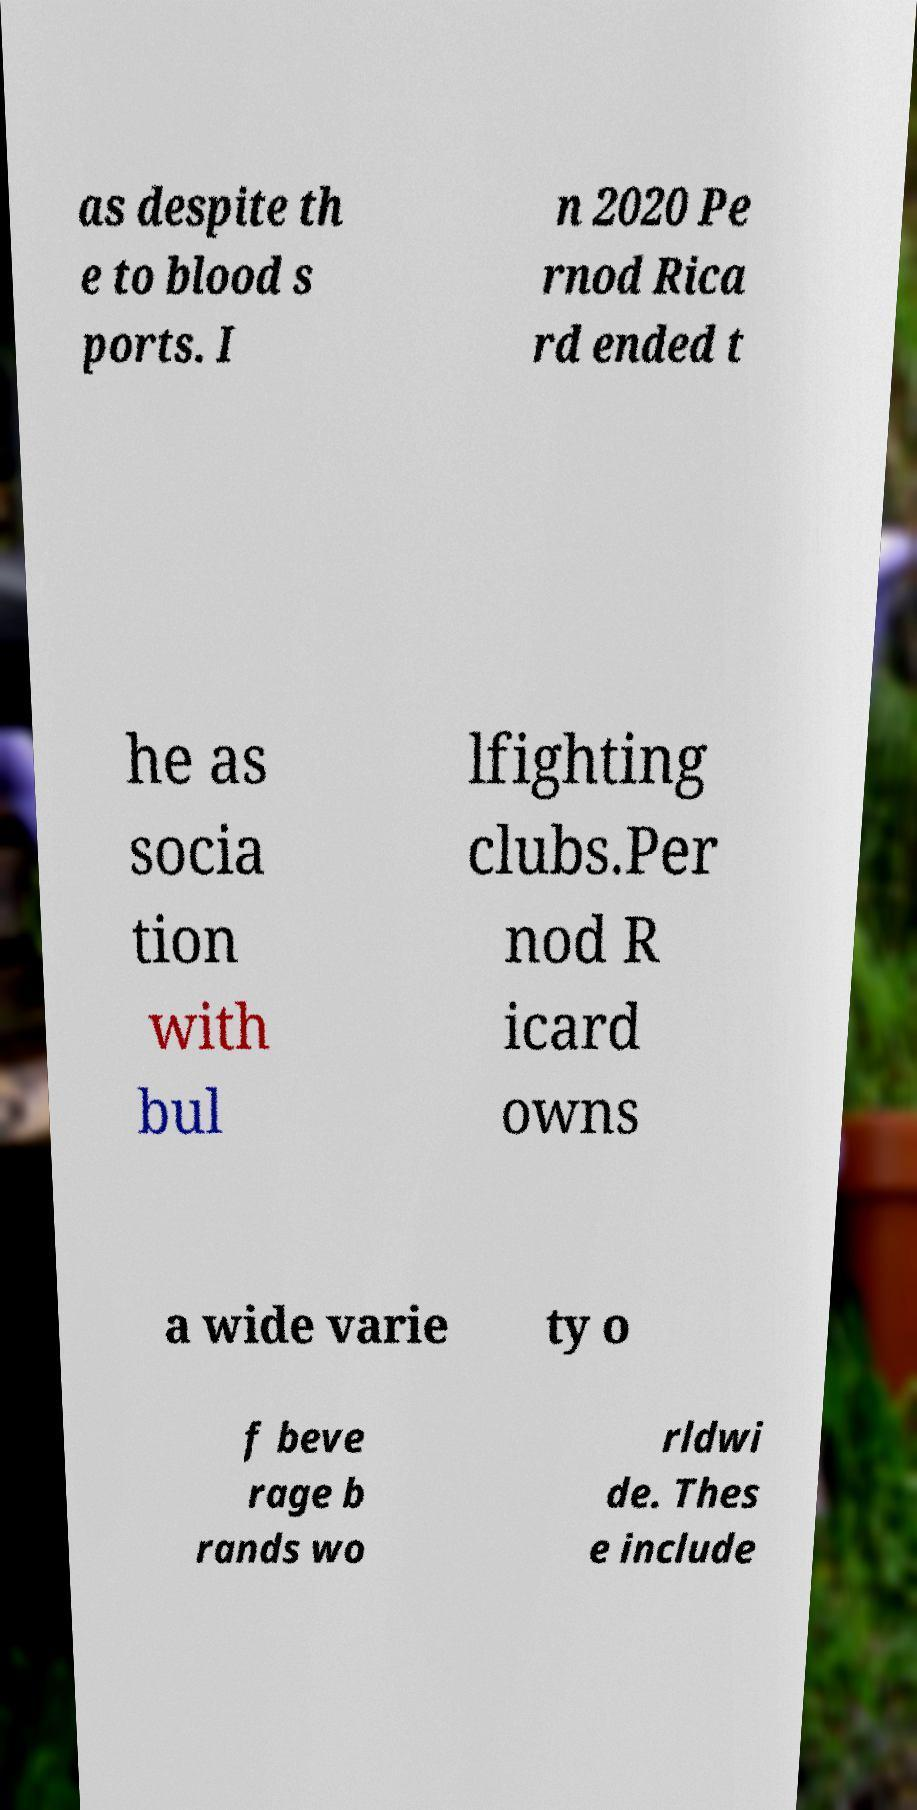Please read and relay the text visible in this image. What does it say? as despite th e to blood s ports. I n 2020 Pe rnod Rica rd ended t he as socia tion with bul lfighting clubs.Per nod R icard owns a wide varie ty o f beve rage b rands wo rldwi de. Thes e include 